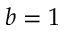<formula> <loc_0><loc_0><loc_500><loc_500>b = 1</formula> 